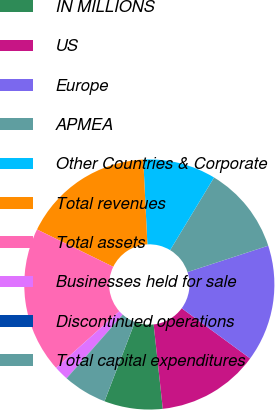Convert chart to OTSL. <chart><loc_0><loc_0><loc_500><loc_500><pie_chart><fcel>IN MILLIONS<fcel>US<fcel>Europe<fcel>APMEA<fcel>Other Countries & Corporate<fcel>Total revenues<fcel>Total assets<fcel>Businesses held for sale<fcel>Discontinued operations<fcel>Total capital expenditures<nl><fcel>7.55%<fcel>13.21%<fcel>15.09%<fcel>11.32%<fcel>9.43%<fcel>16.98%<fcel>18.86%<fcel>1.89%<fcel>0.01%<fcel>5.66%<nl></chart> 